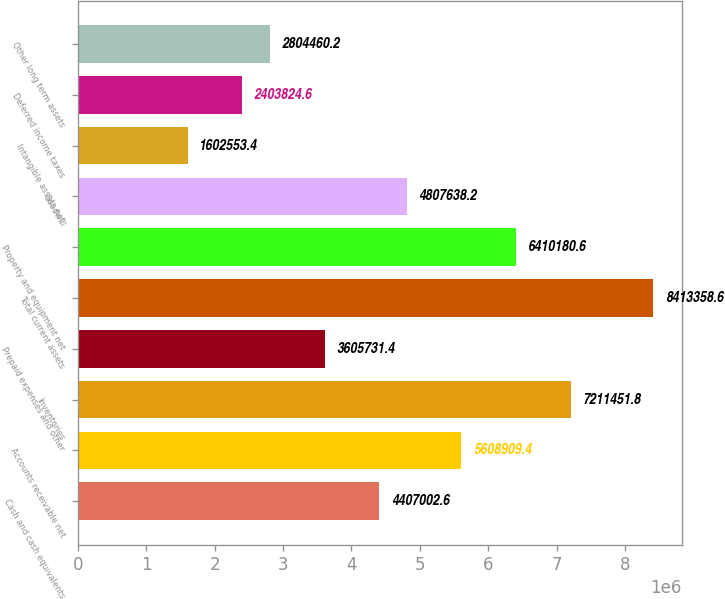Convert chart to OTSL. <chart><loc_0><loc_0><loc_500><loc_500><bar_chart><fcel>Cash and cash equivalents<fcel>Accounts receivable net<fcel>Inventories<fcel>Prepaid expenses and other<fcel>Total current assets<fcel>Property and equipment net<fcel>Goodwill<fcel>Intangible assets net<fcel>Deferred income taxes<fcel>Other long term assets<nl><fcel>4.407e+06<fcel>5.60891e+06<fcel>7.21145e+06<fcel>3.60573e+06<fcel>8.41336e+06<fcel>6.41018e+06<fcel>4.80764e+06<fcel>1.60255e+06<fcel>2.40382e+06<fcel>2.80446e+06<nl></chart> 